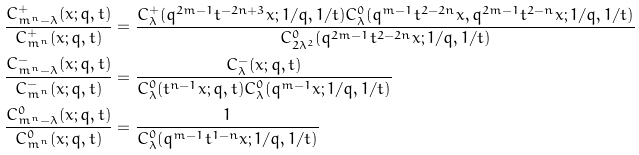Convert formula to latex. <formula><loc_0><loc_0><loc_500><loc_500>\frac { C ^ { + } _ { m ^ { n } - \lambda } ( x ; q , t ) } { C ^ { + } _ { m ^ { n } } ( x ; q , t ) } & = \frac { C ^ { + } _ { \lambda } ( q ^ { 2 m - 1 } t ^ { - 2 n + 3 } x ; 1 / q , 1 / t ) C ^ { 0 } _ { \lambda } ( q ^ { m - 1 } t ^ { 2 - 2 n } x , q ^ { 2 m - 1 } t ^ { 2 - n } x ; 1 / q , 1 / t ) } { C ^ { 0 } _ { 2 \lambda ^ { 2 } } ( q ^ { 2 m - 1 } t ^ { 2 - 2 n } x ; 1 / q , 1 / t ) } \\ \frac { C ^ { - } _ { m ^ { n } - \lambda } ( x ; q , t ) } { C ^ { - } _ { m ^ { n } } ( x ; q , t ) } & = \frac { C ^ { - } _ { \lambda } ( x ; q , t ) } { C ^ { 0 } _ { \lambda } ( t ^ { n - 1 } x ; q , t ) C ^ { 0 } _ { \lambda } ( q ^ { m - 1 } x ; 1 / q , 1 / t ) } \\ \frac { C ^ { 0 } _ { m ^ { n } - \lambda } ( x ; q , t ) } { C ^ { 0 } _ { m ^ { n } } ( x ; q , t ) } & = \frac { 1 } { C ^ { 0 } _ { \lambda } ( q ^ { m - 1 } t ^ { 1 - n } x ; 1 / q , 1 / t ) }</formula> 